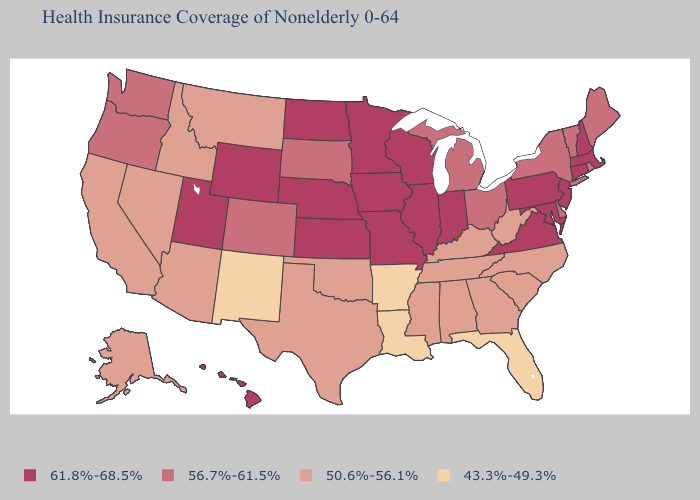Does the first symbol in the legend represent the smallest category?
Short answer required. No. Does Iowa have the lowest value in the MidWest?
Keep it brief. No. How many symbols are there in the legend?
Write a very short answer. 4. Name the states that have a value in the range 43.3%-49.3%?
Write a very short answer. Arkansas, Florida, Louisiana, New Mexico. Does Utah have the highest value in the West?
Short answer required. Yes. Name the states that have a value in the range 56.7%-61.5%?
Quick response, please. Colorado, Delaware, Maine, Michigan, New York, Ohio, Oregon, Rhode Island, South Dakota, Vermont, Washington. Among the states that border Iowa , does South Dakota have the lowest value?
Write a very short answer. Yes. Among the states that border Washington , does Idaho have the highest value?
Give a very brief answer. No. What is the value of Michigan?
Quick response, please. 56.7%-61.5%. What is the value of Oklahoma?
Answer briefly. 50.6%-56.1%. Does North Carolina have the highest value in the South?
Keep it brief. No. What is the value of Florida?
Keep it brief. 43.3%-49.3%. Name the states that have a value in the range 43.3%-49.3%?
Keep it brief. Arkansas, Florida, Louisiana, New Mexico. Among the states that border Missouri , which have the lowest value?
Short answer required. Arkansas. Does Wyoming have the highest value in the West?
Be succinct. Yes. 